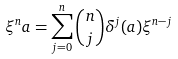<formula> <loc_0><loc_0><loc_500><loc_500>\xi ^ { n } a = \sum _ { j = 0 } ^ { n } \binom { n } { j } \delta ^ { j } ( a ) \xi ^ { n - j }</formula> 